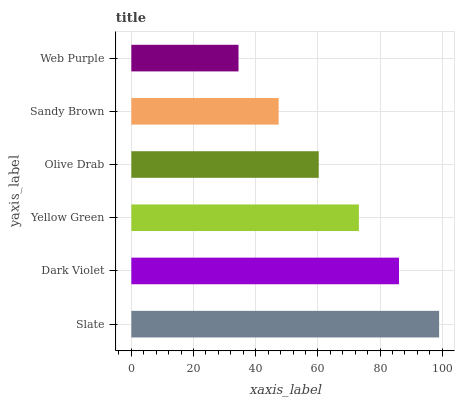Is Web Purple the minimum?
Answer yes or no. Yes. Is Slate the maximum?
Answer yes or no. Yes. Is Dark Violet the minimum?
Answer yes or no. No. Is Dark Violet the maximum?
Answer yes or no. No. Is Slate greater than Dark Violet?
Answer yes or no. Yes. Is Dark Violet less than Slate?
Answer yes or no. Yes. Is Dark Violet greater than Slate?
Answer yes or no. No. Is Slate less than Dark Violet?
Answer yes or no. No. Is Yellow Green the high median?
Answer yes or no. Yes. Is Olive Drab the low median?
Answer yes or no. Yes. Is Olive Drab the high median?
Answer yes or no. No. Is Yellow Green the low median?
Answer yes or no. No. 